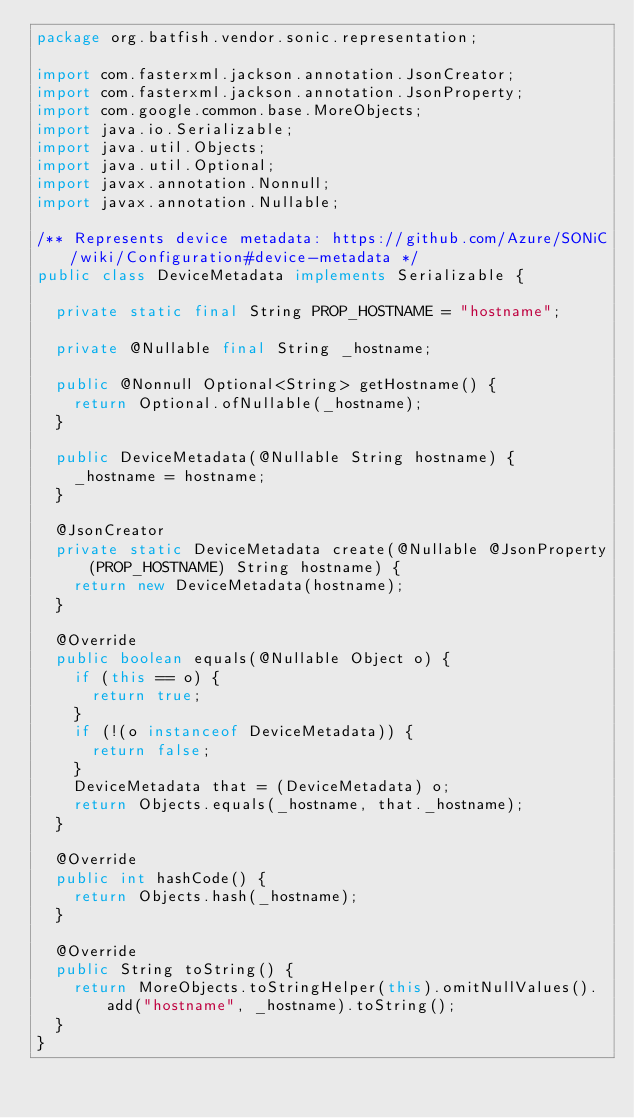Convert code to text. <code><loc_0><loc_0><loc_500><loc_500><_Java_>package org.batfish.vendor.sonic.representation;

import com.fasterxml.jackson.annotation.JsonCreator;
import com.fasterxml.jackson.annotation.JsonProperty;
import com.google.common.base.MoreObjects;
import java.io.Serializable;
import java.util.Objects;
import java.util.Optional;
import javax.annotation.Nonnull;
import javax.annotation.Nullable;

/** Represents device metadata: https://github.com/Azure/SONiC/wiki/Configuration#device-metadata */
public class DeviceMetadata implements Serializable {

  private static final String PROP_HOSTNAME = "hostname";

  private @Nullable final String _hostname;

  public @Nonnull Optional<String> getHostname() {
    return Optional.ofNullable(_hostname);
  }

  public DeviceMetadata(@Nullable String hostname) {
    _hostname = hostname;
  }

  @JsonCreator
  private static DeviceMetadata create(@Nullable @JsonProperty(PROP_HOSTNAME) String hostname) {
    return new DeviceMetadata(hostname);
  }

  @Override
  public boolean equals(@Nullable Object o) {
    if (this == o) {
      return true;
    }
    if (!(o instanceof DeviceMetadata)) {
      return false;
    }
    DeviceMetadata that = (DeviceMetadata) o;
    return Objects.equals(_hostname, that._hostname);
  }

  @Override
  public int hashCode() {
    return Objects.hash(_hostname);
  }

  @Override
  public String toString() {
    return MoreObjects.toStringHelper(this).omitNullValues().add("hostname", _hostname).toString();
  }
}
</code> 